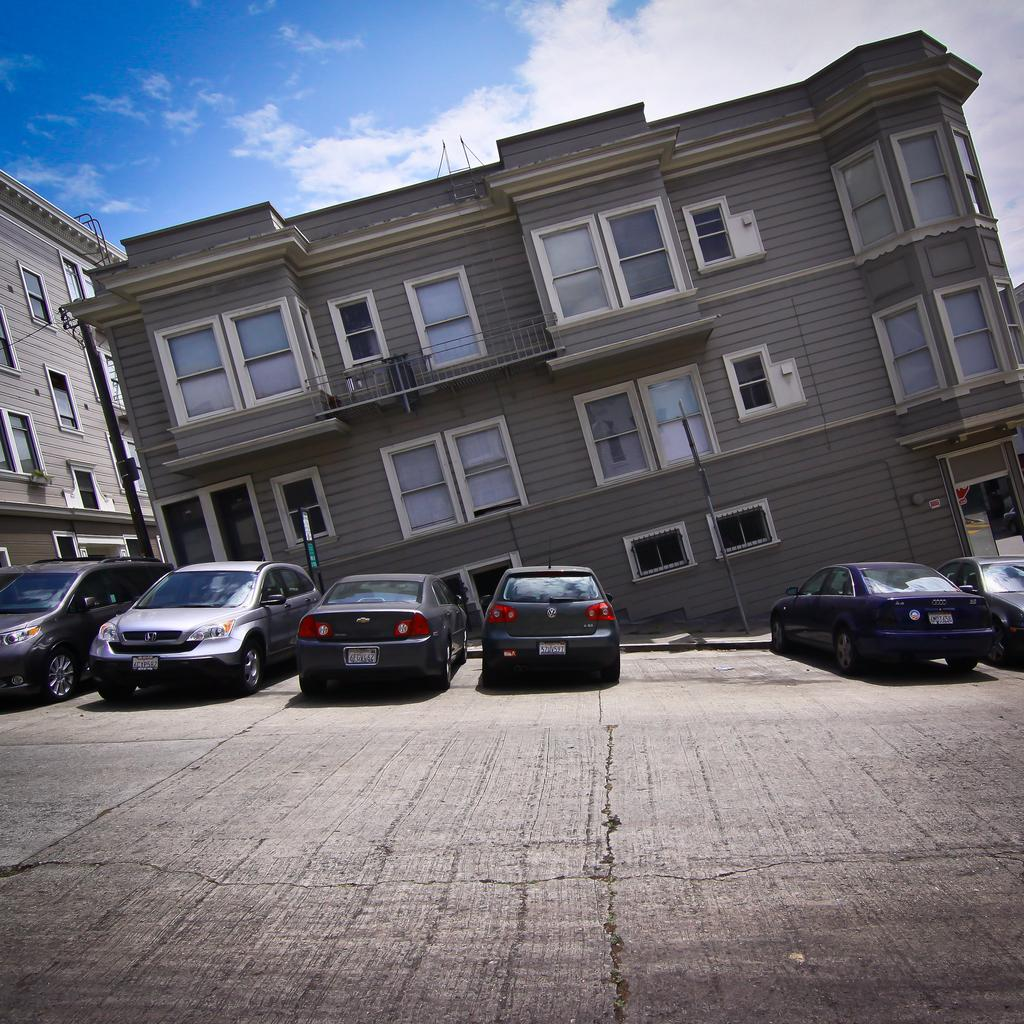How many buildings can be seen in the image? There are two buildings in the image. What is located in front of the buildings? There are cars parked on the road in front of the buildings. What type of mark is visible on the government building in the image? There is no mention of a government building or any mark in the image. 